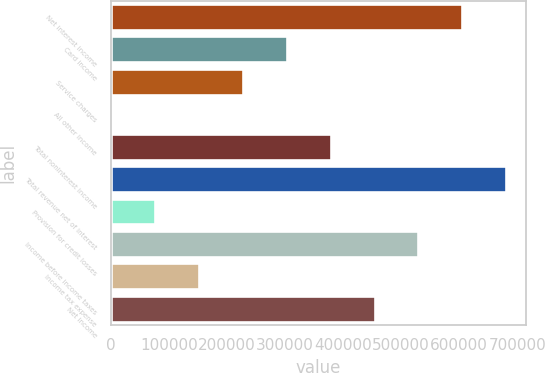Convert chart to OTSL. <chart><loc_0><loc_0><loc_500><loc_500><bar_chart><fcel>Net interest income<fcel>Card income<fcel>Service charges<fcel>All other income<fcel>Total noninterest income<fcel>Total revenue net of interest<fcel>Provision for credit losses<fcel>Income before income taxes<fcel>Income tax expense<fcel>Net income<nl><fcel>605261<fcel>303036<fcel>227480<fcel>811<fcel>378592<fcel>680817<fcel>76367.2<fcel>529704<fcel>151923<fcel>454148<nl></chart> 